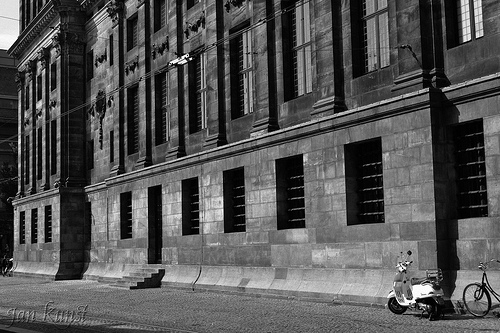Do you see a scooter beside the building? No, there is no scooter beside the building in the image. 